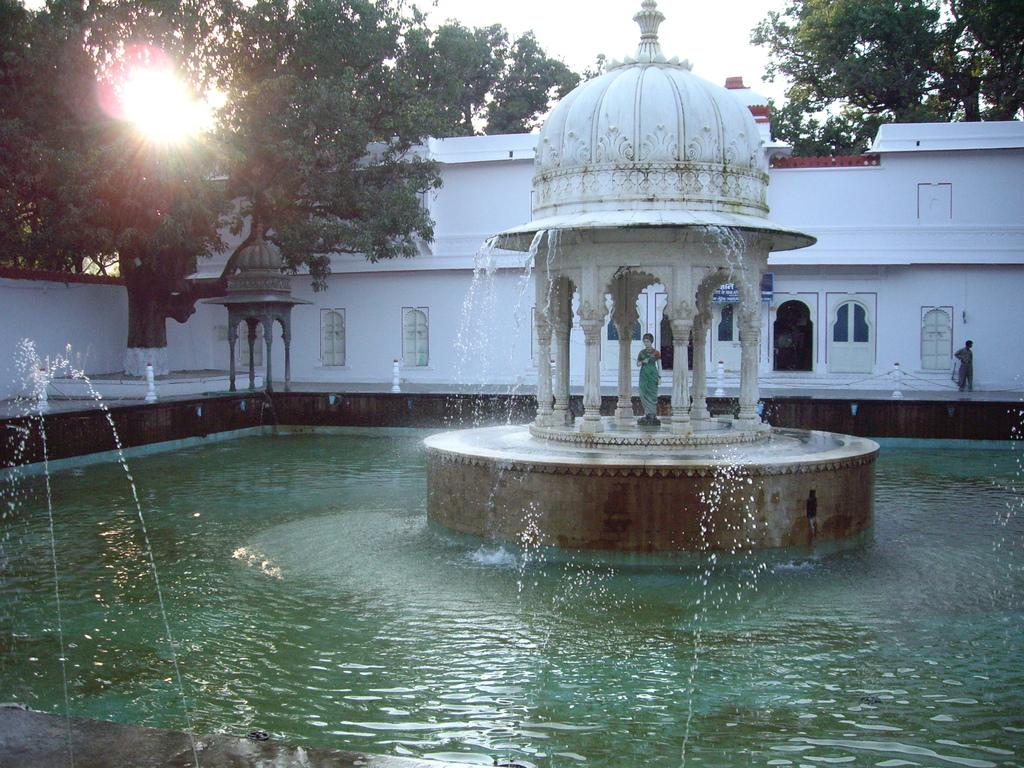What is present at the bottom of the image? There is water at the bottom of the image. What structure is visible in the foreground? There is a roof with pillars in the foreground. What can be seen in the background of the image? There is a building and trees in the background. What is visible at the top of the image? The sky is visible at the top of the image. Where is the fuel tank located in the image? There is no fuel tank present in the image. What type of pot is being used to dig a hole in the image? There is no pot or hole present in the image. 